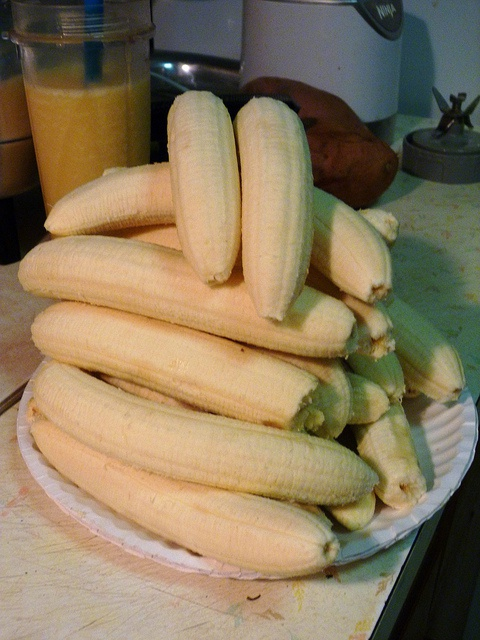Describe the objects in this image and their specific colors. I can see banana in black, tan, and olive tones, dining table in black, tan, and gray tones, cup in black and olive tones, and dining table in black, gray, teal, and darkgreen tones in this image. 